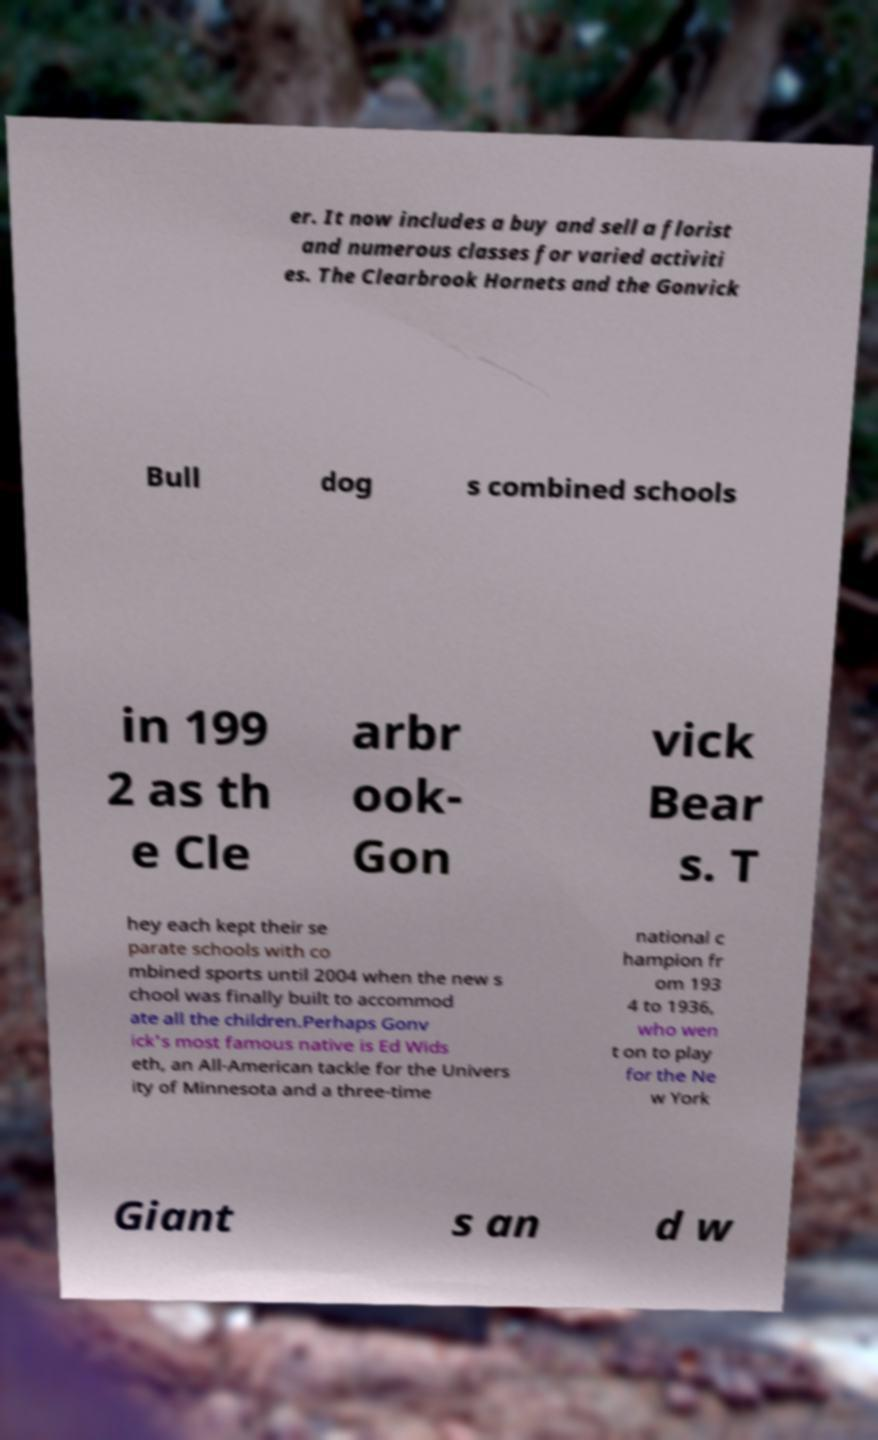Could you assist in decoding the text presented in this image and type it out clearly? er. It now includes a buy and sell a florist and numerous classes for varied activiti es. The Clearbrook Hornets and the Gonvick Bull dog s combined schools in 199 2 as th e Cle arbr ook- Gon vick Bear s. T hey each kept their se parate schools with co mbined sports until 2004 when the new s chool was finally built to accommod ate all the children.Perhaps Gonv ick's most famous native is Ed Wids eth, an All-American tackle for the Univers ity of Minnesota and a three-time national c hampion fr om 193 4 to 1936, who wen t on to play for the Ne w York Giant s an d w 